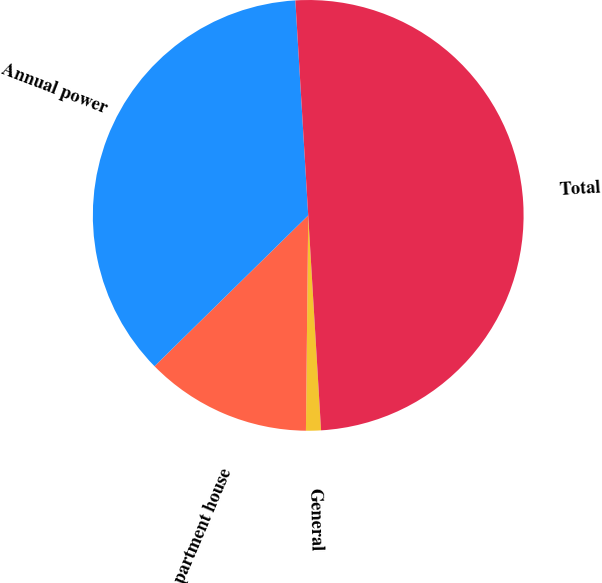<chart> <loc_0><loc_0><loc_500><loc_500><pie_chart><fcel>General<fcel>Apartment house<fcel>Annual power<fcel>Total<nl><fcel>1.12%<fcel>12.48%<fcel>36.4%<fcel>50.0%<nl></chart> 